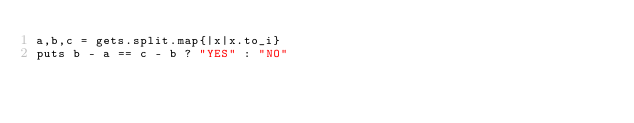Convert code to text. <code><loc_0><loc_0><loc_500><loc_500><_Ruby_>a,b,c = gets.split.map{|x|x.to_i}
puts b - a == c - b ? "YES" : "NO"</code> 